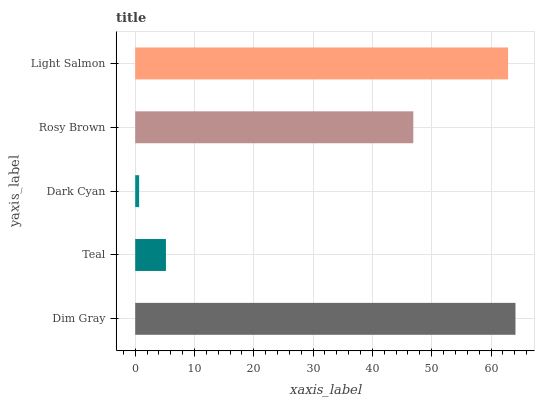Is Dark Cyan the minimum?
Answer yes or no. Yes. Is Dim Gray the maximum?
Answer yes or no. Yes. Is Teal the minimum?
Answer yes or no. No. Is Teal the maximum?
Answer yes or no. No. Is Dim Gray greater than Teal?
Answer yes or no. Yes. Is Teal less than Dim Gray?
Answer yes or no. Yes. Is Teal greater than Dim Gray?
Answer yes or no. No. Is Dim Gray less than Teal?
Answer yes or no. No. Is Rosy Brown the high median?
Answer yes or no. Yes. Is Rosy Brown the low median?
Answer yes or no. Yes. Is Teal the high median?
Answer yes or no. No. Is Dark Cyan the low median?
Answer yes or no. No. 